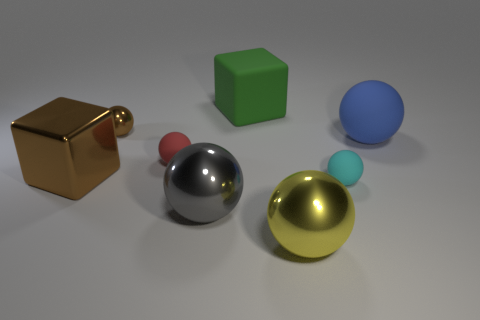The other tiny rubber object that is the same shape as the small red matte object is what color? The tiny rubber object that mirrors the shape of the small red matte sphere is cyan. 